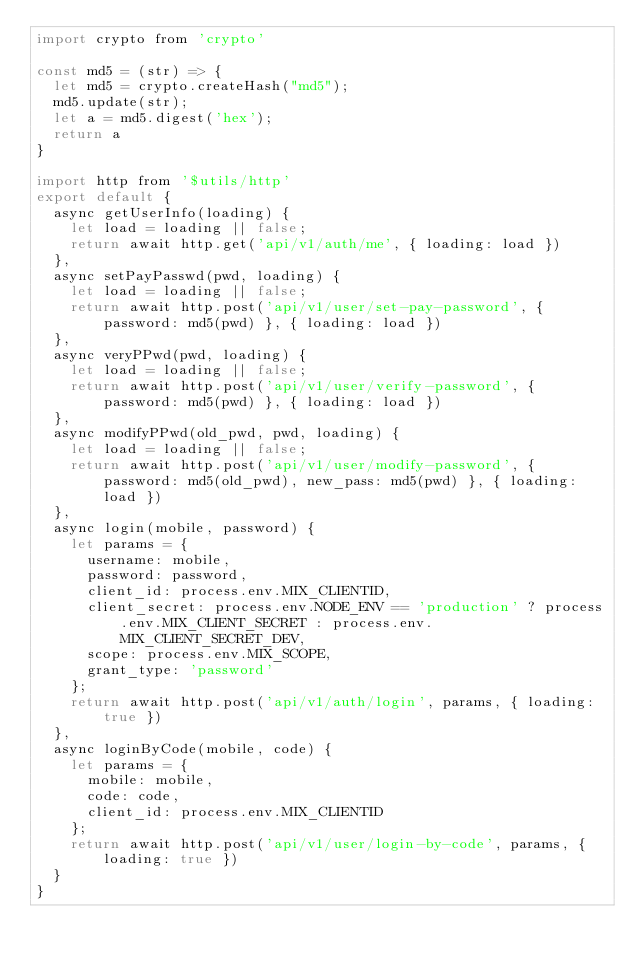<code> <loc_0><loc_0><loc_500><loc_500><_JavaScript_>import crypto from 'crypto'

const md5 = (str) => {
  let md5 = crypto.createHash("md5");
  md5.update(str);
  let a = md5.digest('hex');
  return a
}

import http from '$utils/http'
export default {
  async getUserInfo(loading) {
    let load = loading || false;
    return await http.get('api/v1/auth/me', { loading: load })
  },
  async setPayPasswd(pwd, loading) {
    let load = loading || false;
    return await http.post('api/v1/user/set-pay-password', { password: md5(pwd) }, { loading: load })
  },
  async veryPPwd(pwd, loading) {
    let load = loading || false;
    return await http.post('api/v1/user/verify-password', { password: md5(pwd) }, { loading: load })
  },
  async modifyPPwd(old_pwd, pwd, loading) {
    let load = loading || false;
    return await http.post('api/v1/user/modify-password', { password: md5(old_pwd), new_pass: md5(pwd) }, { loading: load })
  },
  async login(mobile, password) {
    let params = {
      username: mobile,
      password: password,
      client_id: process.env.MIX_CLIENTID,
      client_secret: process.env.NODE_ENV == 'production' ? process.env.MIX_CLIENT_SECRET : process.env.MIX_CLIENT_SECRET_DEV,
      scope: process.env.MIX_SCOPE,
      grant_type: 'password'
    };
    return await http.post('api/v1/auth/login', params, { loading: true })
  },
  async loginByCode(mobile, code) {
    let params = {
      mobile: mobile,
      code: code,
      client_id: process.env.MIX_CLIENTID
    };
    return await http.post('api/v1/user/login-by-code', params, { loading: true })
  }
}
</code> 